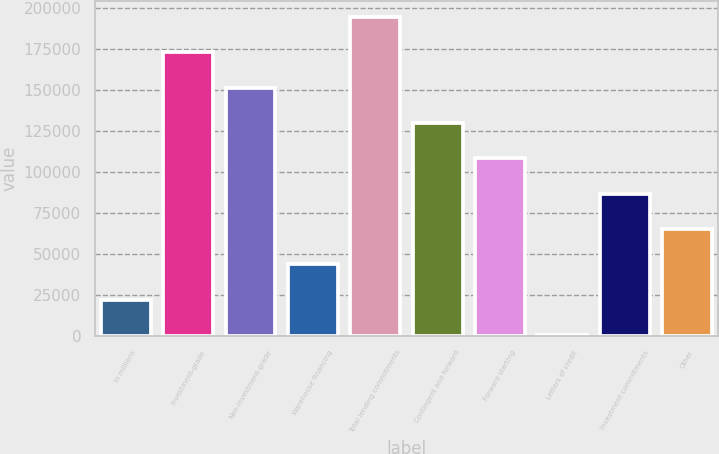Convert chart. <chart><loc_0><loc_0><loc_500><loc_500><bar_chart><fcel>in millions<fcel>Investment-grade<fcel>Non-investment-grade<fcel>Warehouse financing<fcel>Total lending commitments<fcel>Contingent and forward<fcel>Forward starting<fcel>Letters of credit<fcel>Investment commitments<fcel>Other<nl><fcel>21992.4<fcel>172880<fcel>151325<fcel>43547.8<fcel>194436<fcel>129769<fcel>108214<fcel>437<fcel>86658.6<fcel>65103.2<nl></chart> 